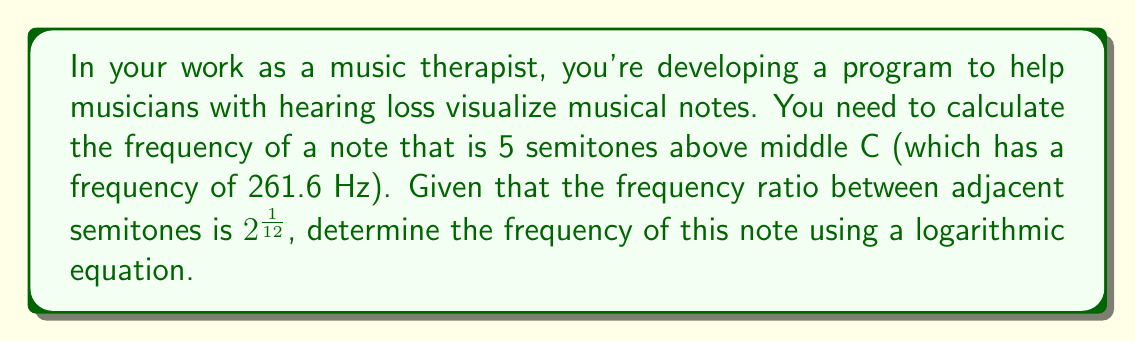Show me your answer to this math problem. Let's approach this step-by-step:

1) We know that the frequency ratio between adjacent semitones is $2^{\frac{1}{12}}$.

2) For n semitones above a given frequency f, the new frequency f' is given by:

   $$f' = f \cdot (2^{\frac{1}{12}})^n$$

3) In this case, f = 261.6 Hz (middle C) and n = 5 semitones.

4) Let's substitute these values:

   $$f' = 261.6 \cdot (2^{\frac{1}{12}})^5$$

5) We can simplify the exponent:

   $$f' = 261.6 \cdot 2^{\frac{5}{12}}$$

6) Now, we can calculate this:
   
   $$f' = 261.6 \cdot 1.3348398541700344$$

7) Which gives us:

   $$f' \approx 349.2 \text{ Hz}$$

This frequency corresponds to the note F4, which is indeed 5 semitones above middle C (C4).
Answer: 349.2 Hz 